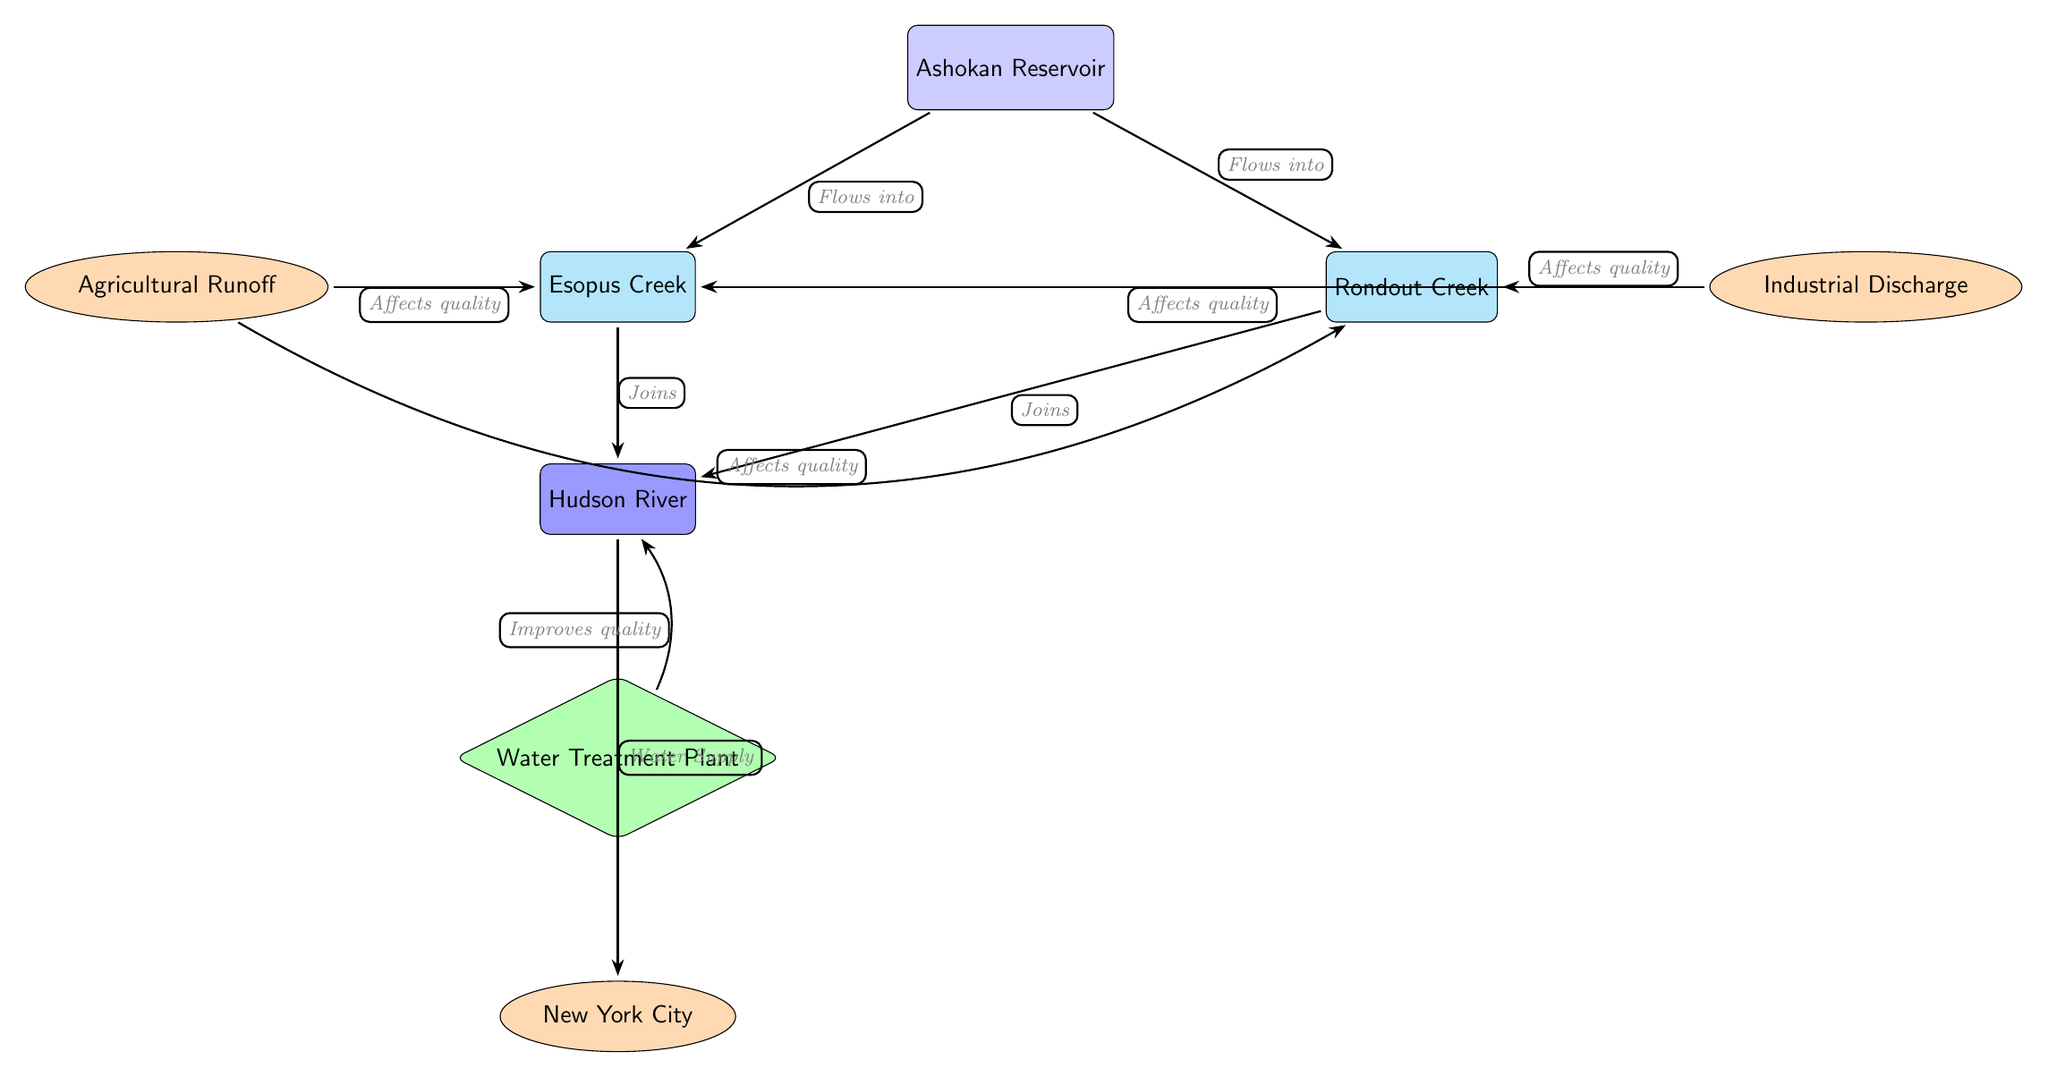What is the source of the water in this diagram? The diagram shows "Ashokan Reservoir" labeled as the source, indicating that it is the origin of the water flow in this watershed area.
Answer: Ashokan Reservoir How many tributaries are shown in the diagram? By counting the nodes connected to the source that are labeled as tributaries, we see there are two tributaries: Esopus Creek and Rondout Creek, thus the total is two.
Answer: 2 Which human influence affects Esopus Creek? "Agricultural Runoff" is shown to the left of Esopus Creek and is indicated to affect its quality, which identifies it as the relevant human influence impacting Esopus Creek.
Answer: Agricultural Runoff What river do the tributaries join? Esopus Creek and Rondout Creek both flow into "Hudson River," which is indicated as the downstream river joining these tributaries.
Answer: Hudson River What is the role of the Water Treatment Plant in the diagram? The diagram indicates that the "Water Treatment Plant" improves the quality of water flowing from the downstream river to the city, illustrating its function in water quality management for urban needs.
Answer: Improves quality Which city is the final destination for the water supply? The diagram points directly from the "Hudson River" to "New York City," establishing that the water flows towards New York City as its final destination.
Answer: New York City How many instances of human influence can be identified in the diagram? There are three distinct human influences labeled: Agricultural Runoff, Industrial Discharge, and a Water Treatment Plant, totaling three instances of human influence depicted.
Answer: 3 Which tributary joins the downstream river first? The diagram does not specify a first tributary joining; however, it shows both tributaries, Esopus Creek and Rondout Creek, joining together into the Hudson River, implying they are simultaneous.
Answer: Not specified What type of discharge affects Rondout Creek? The diagram reveals "Industrial Discharge" as the human influence indicated to affect the quality of water in Rondout Creek.
Answer: Industrial Discharge 